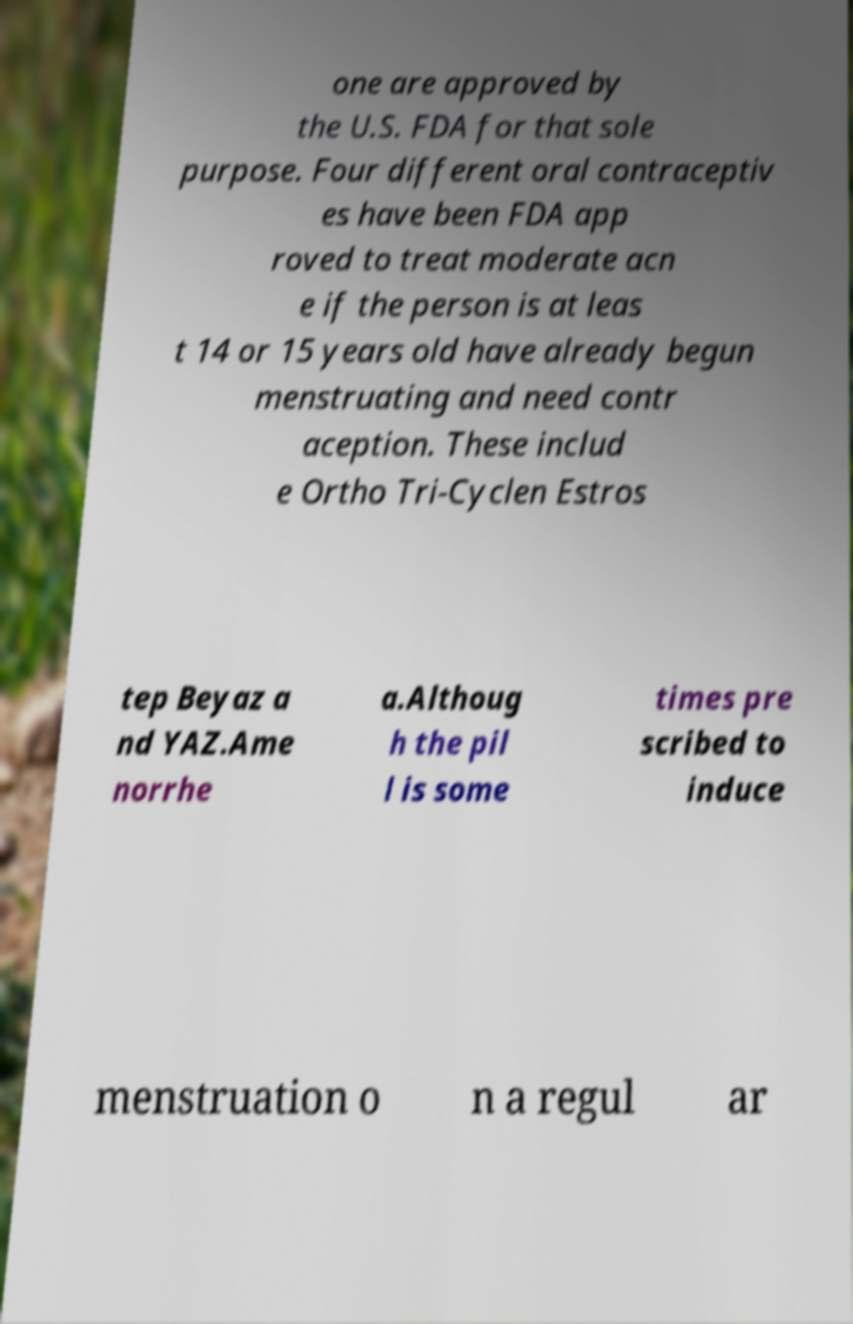Please identify and transcribe the text found in this image. one are approved by the U.S. FDA for that sole purpose. Four different oral contraceptiv es have been FDA app roved to treat moderate acn e if the person is at leas t 14 or 15 years old have already begun menstruating and need contr aception. These includ e Ortho Tri-Cyclen Estros tep Beyaz a nd YAZ.Ame norrhe a.Althoug h the pil l is some times pre scribed to induce menstruation o n a regul ar 